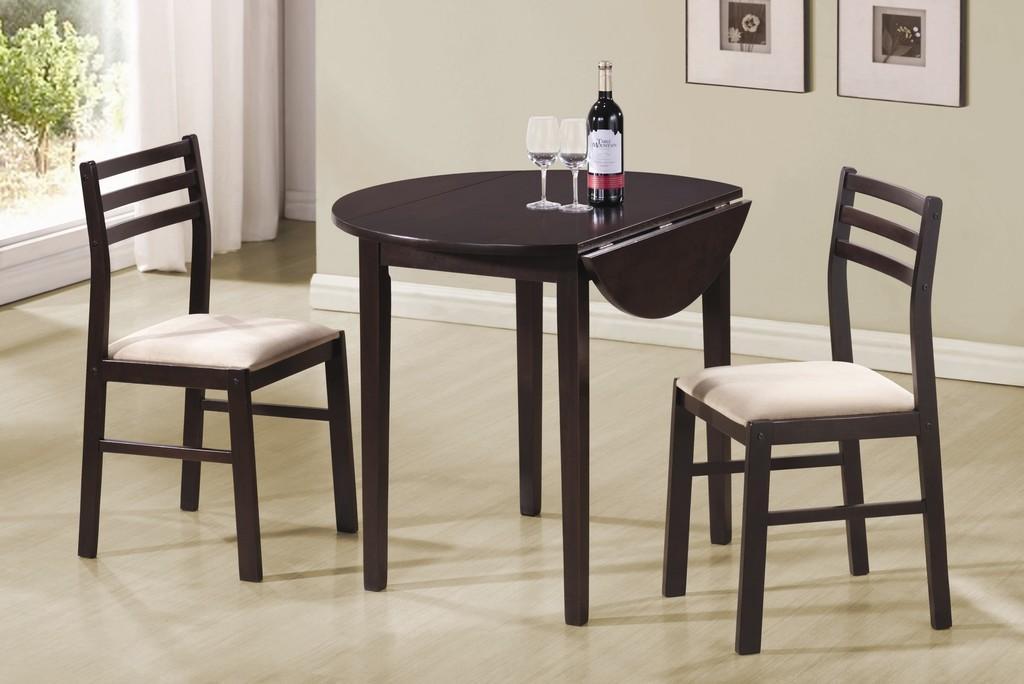In one or two sentences, can you explain what this image depicts? In this picture we can observe a table on which a wine bottle and two glasses were placed. There are two chairs. In the background there are some photo frames fixed to the wall. In the left side there is a white color curtain and a glass door, through which we can observe some plants. 